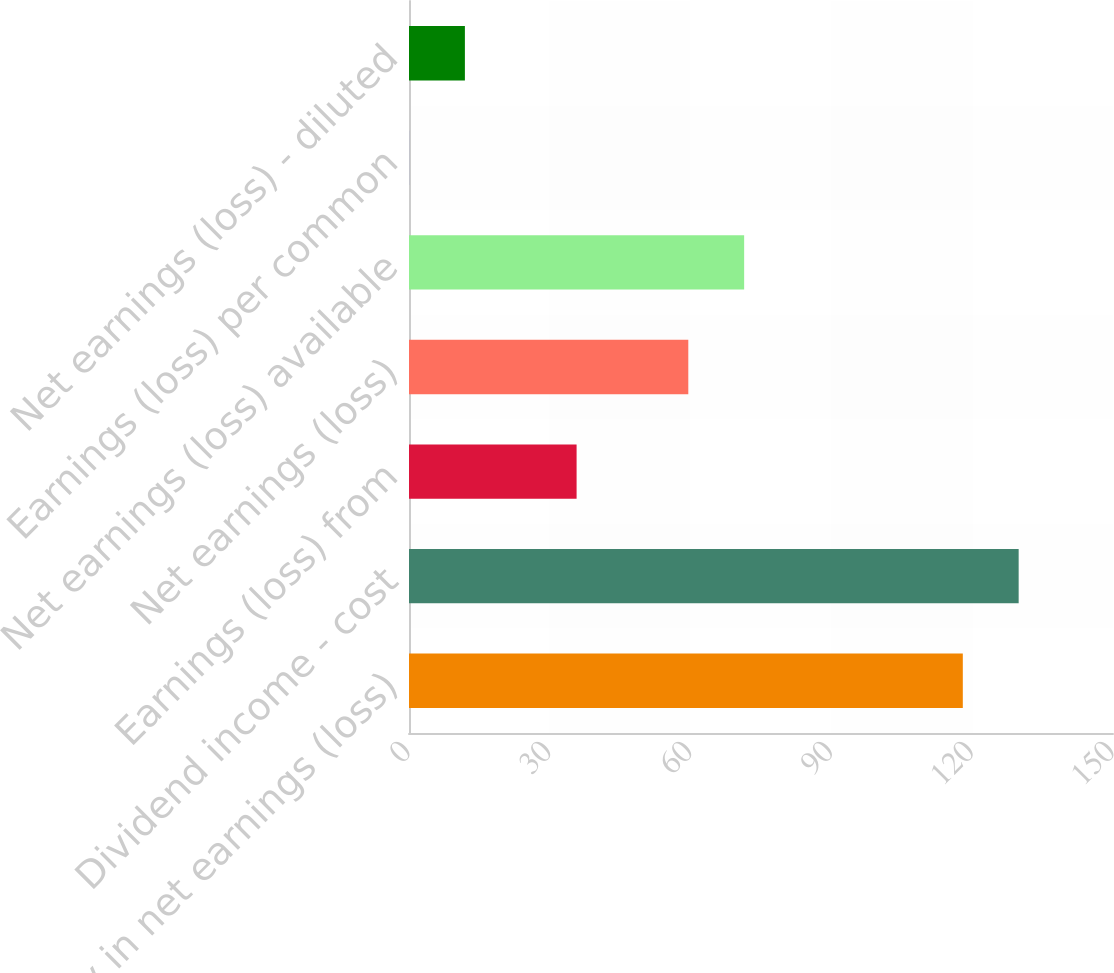Convert chart to OTSL. <chart><loc_0><loc_0><loc_500><loc_500><bar_chart><fcel>Equity in net earnings (loss)<fcel>Dividend income - cost<fcel>Earnings (loss) from<fcel>Net earnings (loss)<fcel>Net earnings (loss) available<fcel>Earnings (loss) per common<fcel>Net earnings (loss) - diluted<nl><fcel>118<fcel>129.9<fcel>35.71<fcel>59.51<fcel>71.41<fcel>0.01<fcel>11.91<nl></chart> 